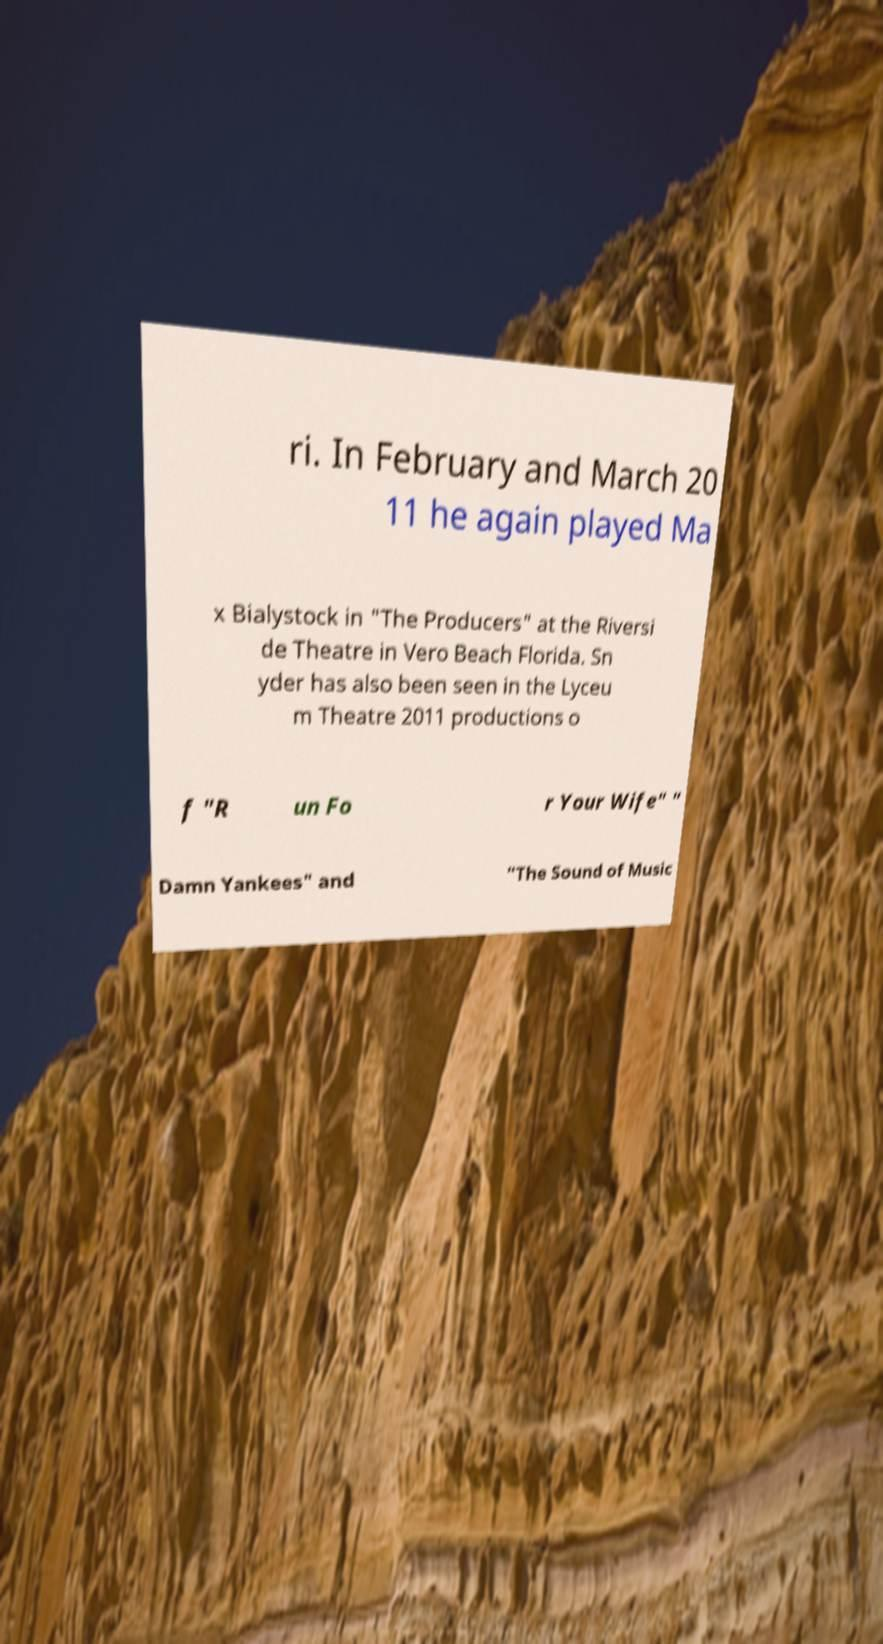I need the written content from this picture converted into text. Can you do that? ri. In February and March 20 11 he again played Ma x Bialystock in "The Producers" at the Riversi de Theatre in Vero Beach Florida. Sn yder has also been seen in the Lyceu m Theatre 2011 productions o f "R un Fo r Your Wife" " Damn Yankees" and "The Sound of Music 